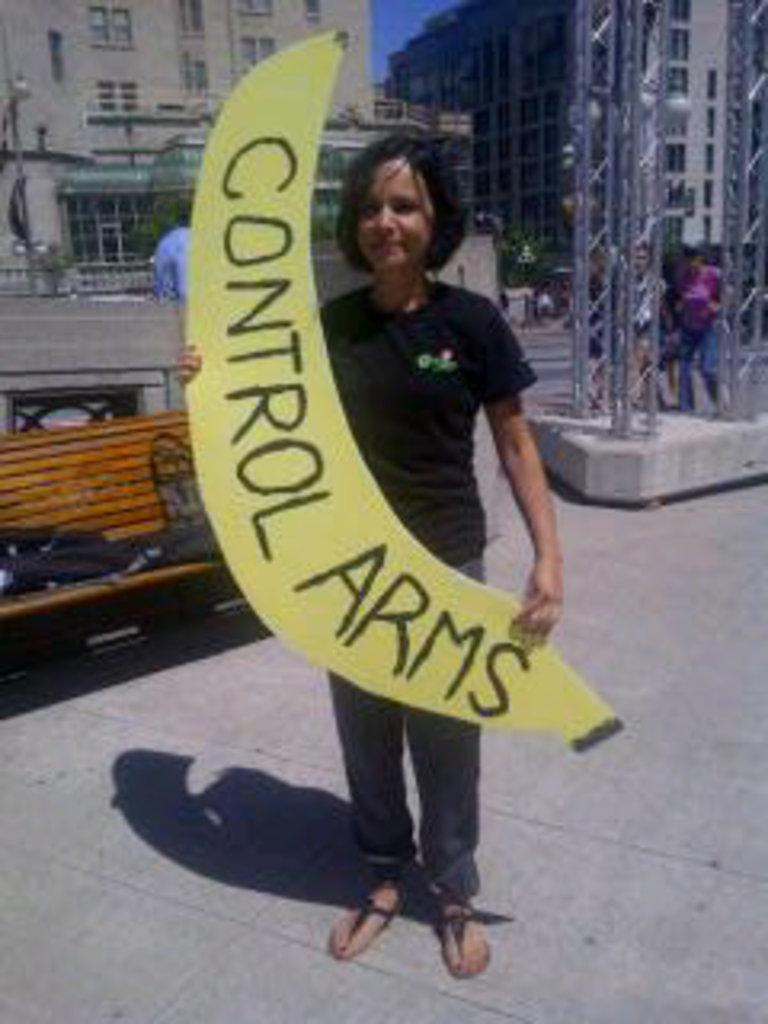Who is the main subject in the image? There is a boy in the image. What is the boy wearing? The boy is wearing a black t-shirt. What is the boy holding in the image? The boy is holding a banner. What type of seating is visible in the image? There is a bench in the image. How many people are present in the image? There are people in the image. What type of structure is visible in the image? There is a building in the image. What type of instrument is the boy playing in the image? There is no instrument present in the image; the boy is holding a banner. 